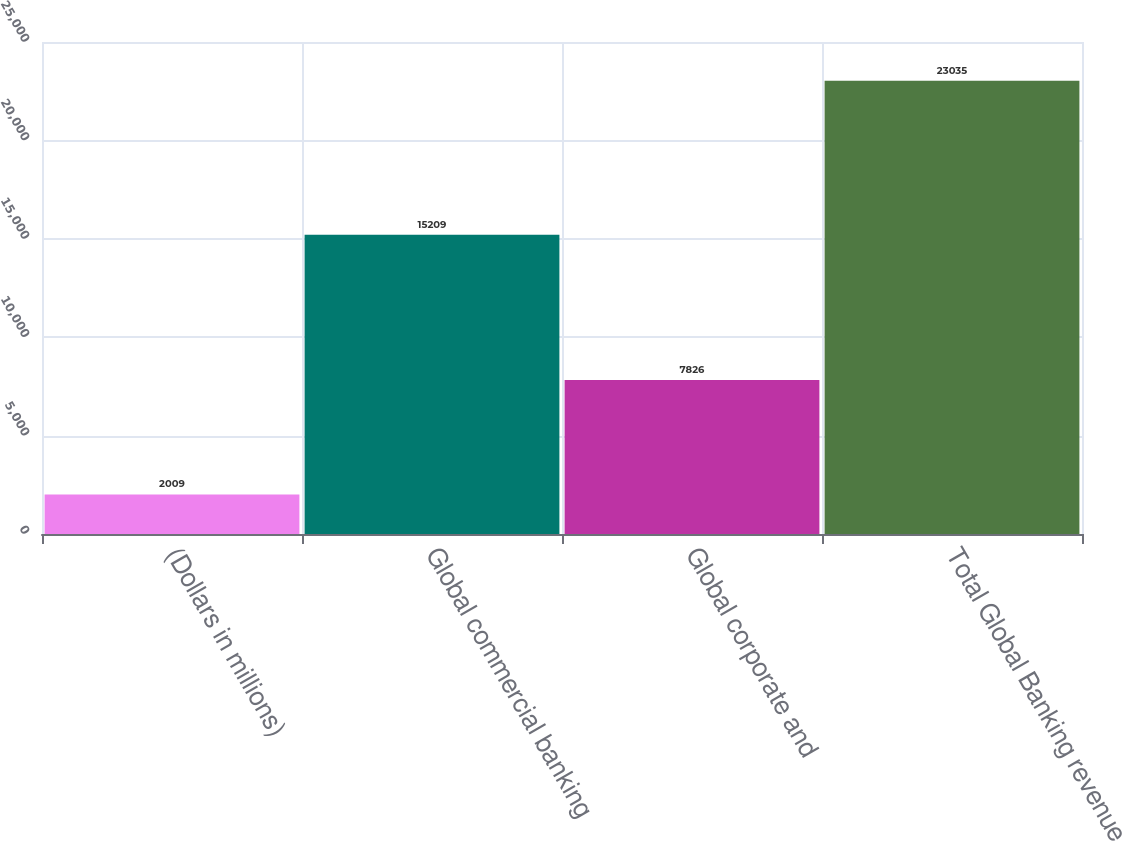Convert chart. <chart><loc_0><loc_0><loc_500><loc_500><bar_chart><fcel>(Dollars in millions)<fcel>Global commercial banking<fcel>Global corporate and<fcel>Total Global Banking revenue<nl><fcel>2009<fcel>15209<fcel>7826<fcel>23035<nl></chart> 